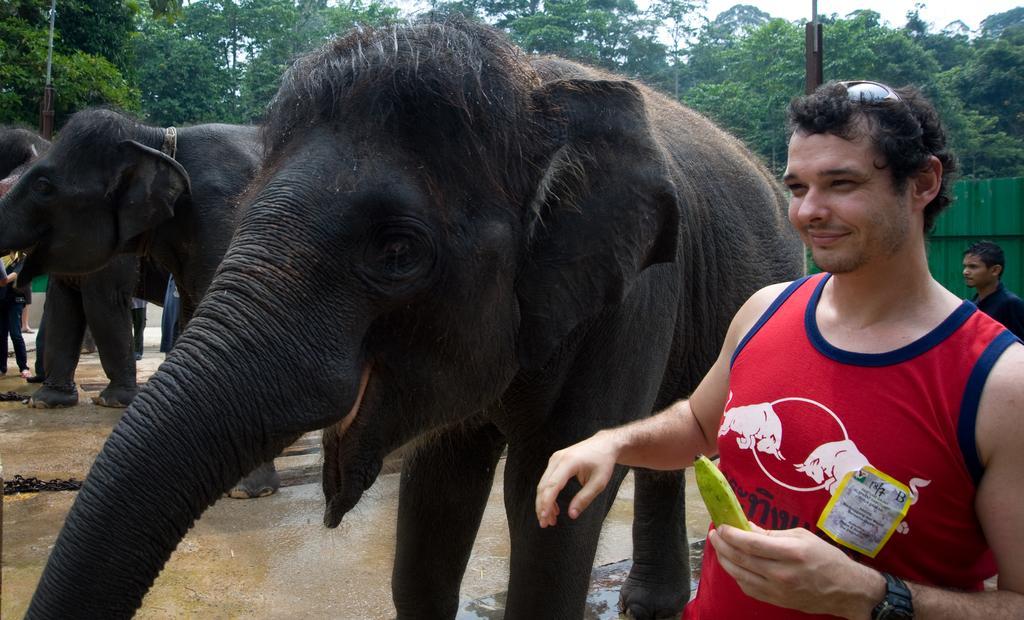Please provide a concise description of this image. In this image I can see few people and few elephants are standing. On the right side of this image I can see a man is holding a banana and on his head I can see the black shades. In the background I can see the green colour wall, few poles, number of trees and the sky. 